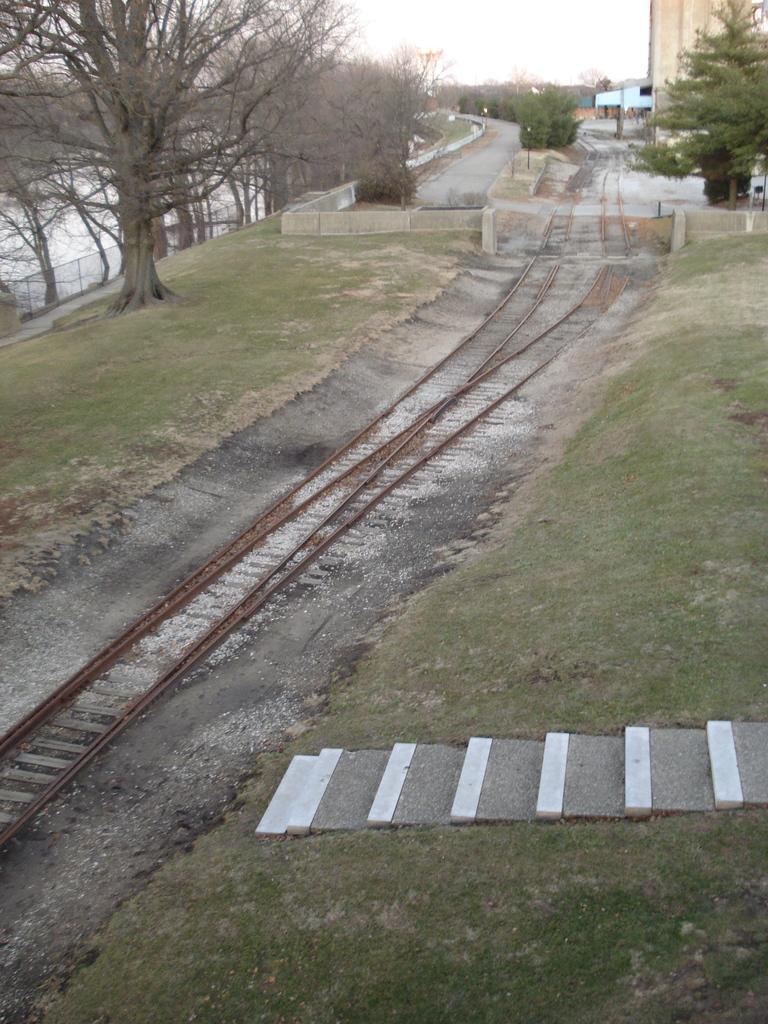Can you describe this image briefly? In this image we can see a railway track, staircase, building. In the background, we can see a group of trees, fence and a sky. 